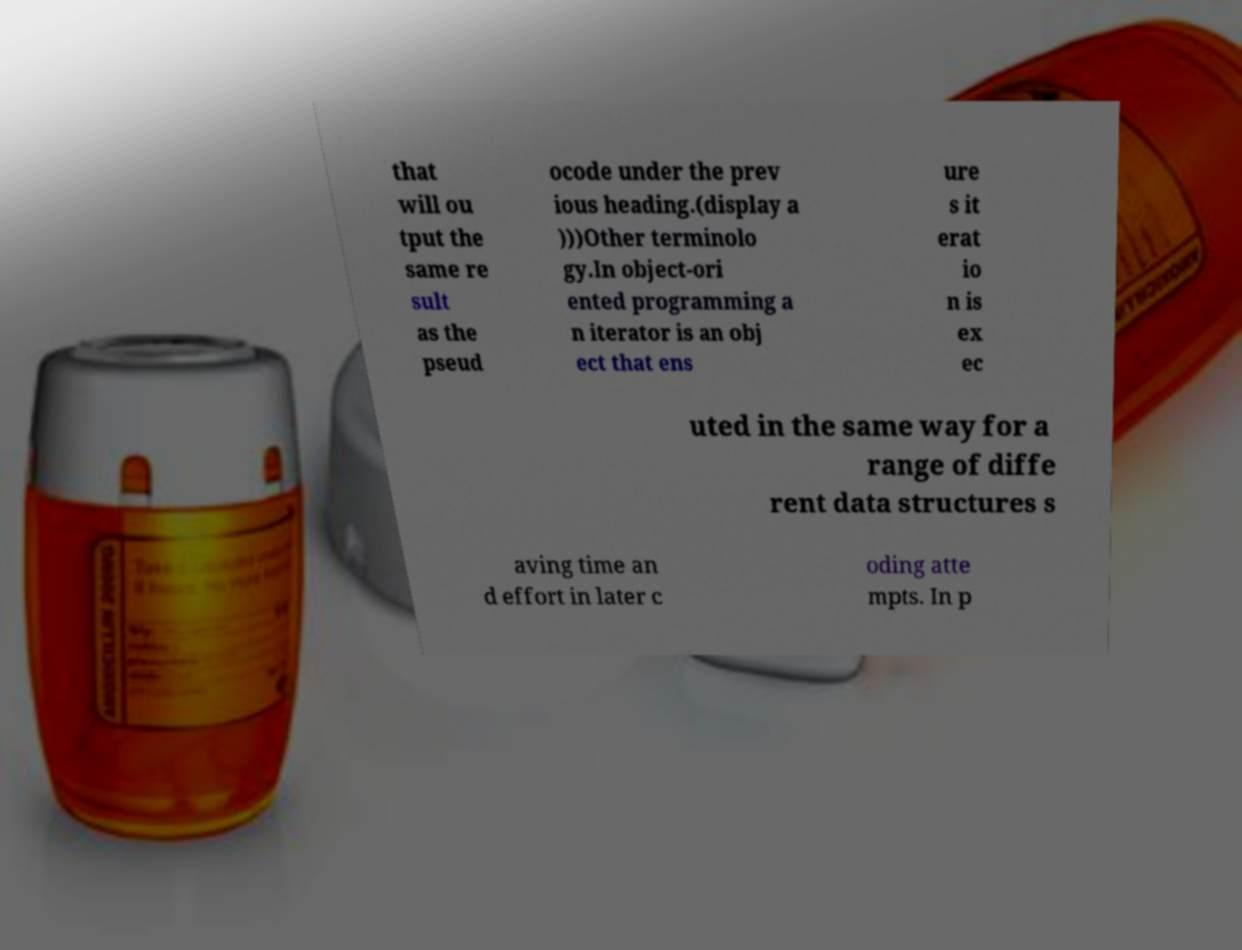I need the written content from this picture converted into text. Can you do that? that will ou tput the same re sult as the pseud ocode under the prev ious heading.(display a )))Other terminolo gy.In object-ori ented programming a n iterator is an obj ect that ens ure s it erat io n is ex ec uted in the same way for a range of diffe rent data structures s aving time an d effort in later c oding atte mpts. In p 